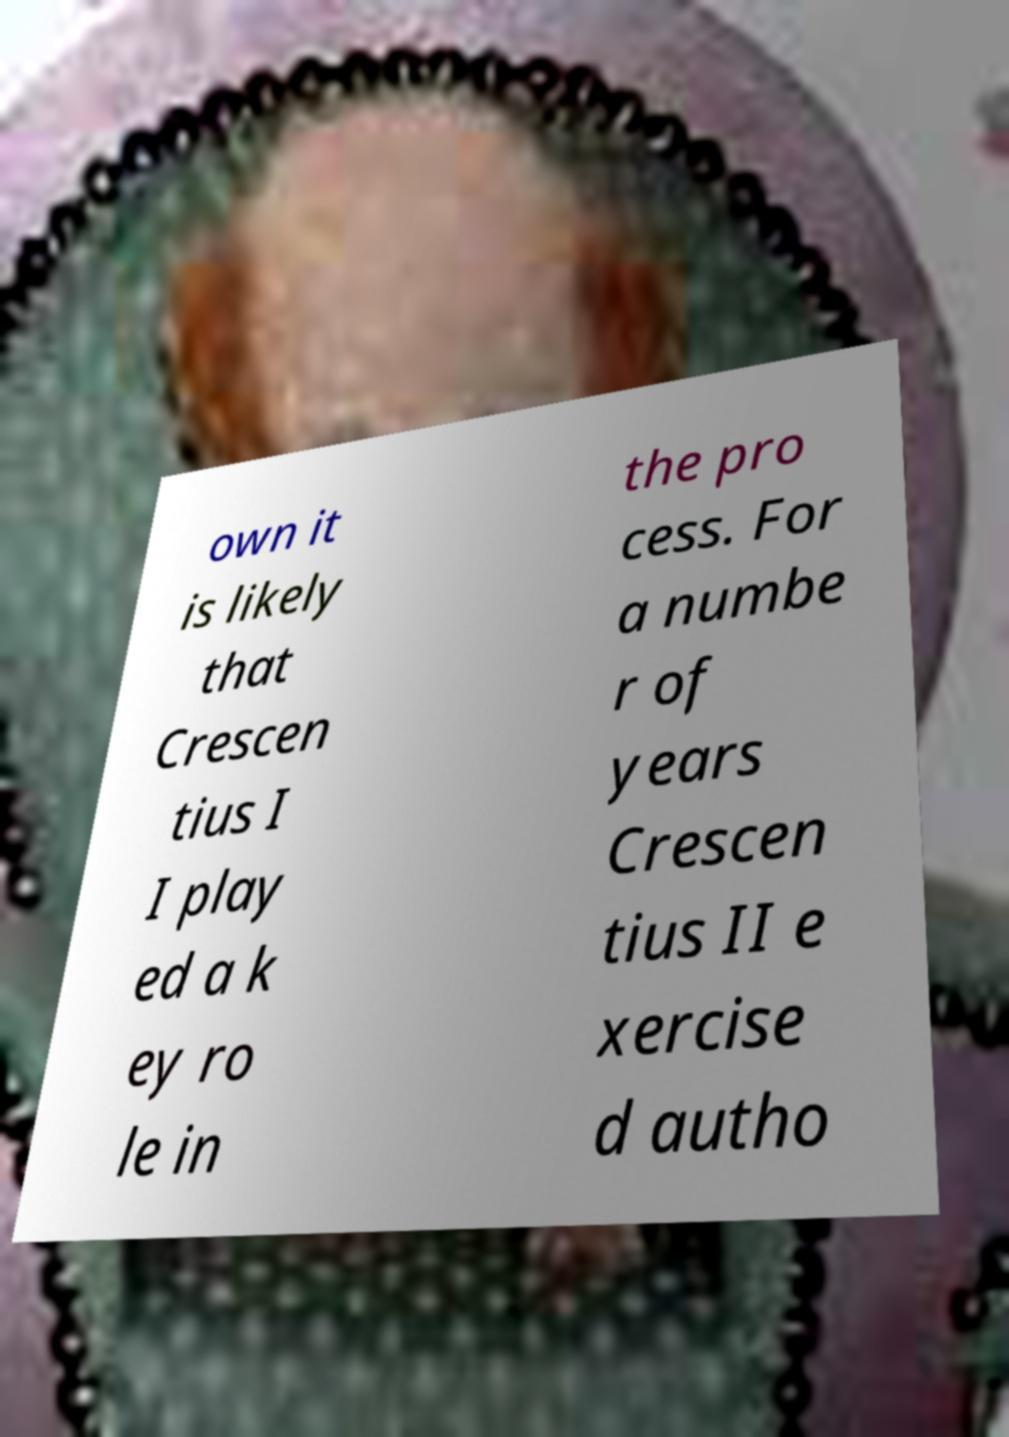Can you read and provide the text displayed in the image?This photo seems to have some interesting text. Can you extract and type it out for me? own it is likely that Crescen tius I I play ed a k ey ro le in the pro cess. For a numbe r of years Crescen tius II e xercise d autho 